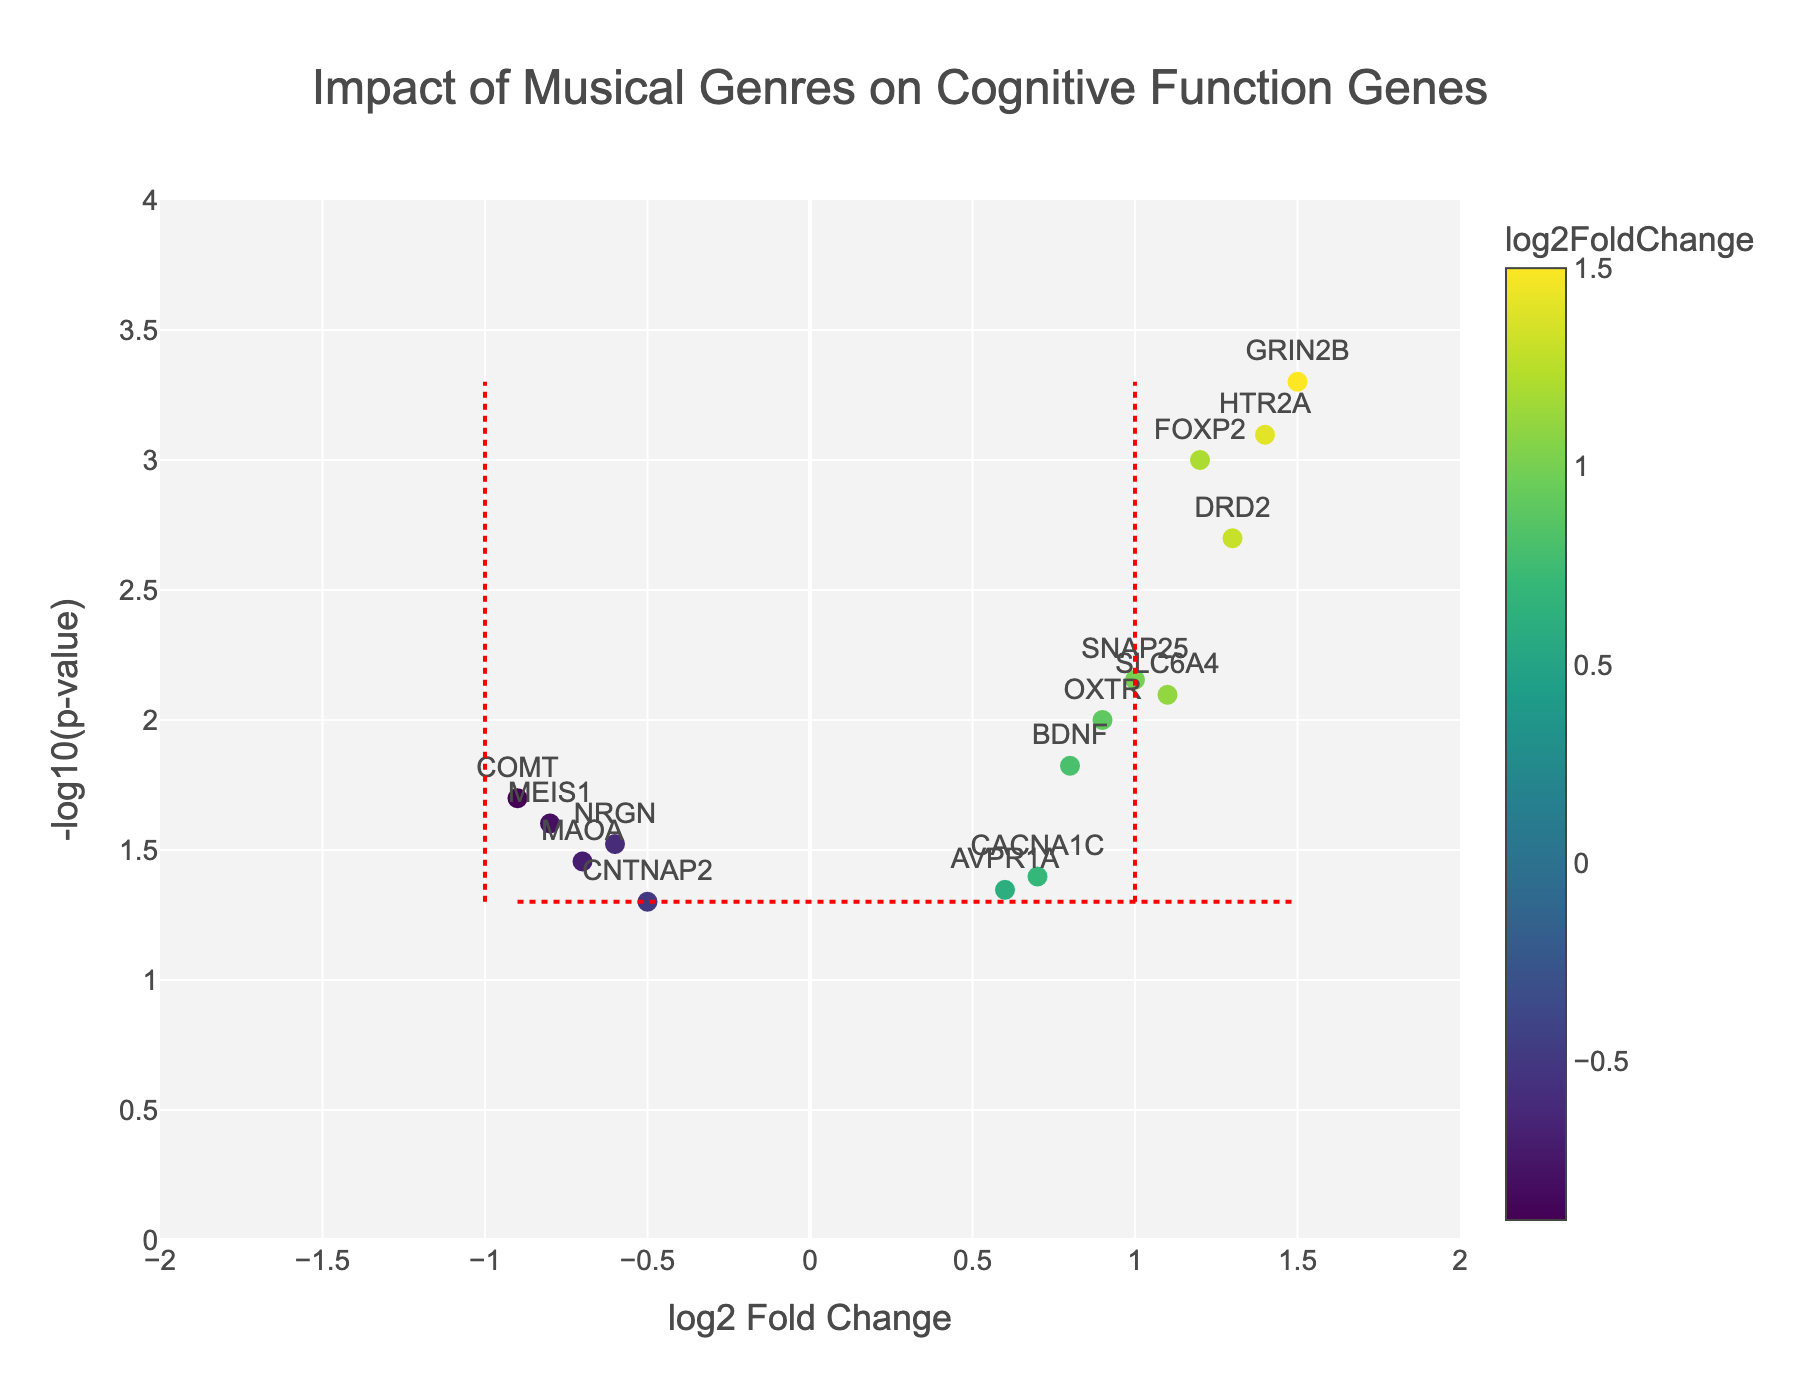Which gene has the highest -log10(p-value)? By looking at the y-axis, which represents -log10(p-value), the gene with the highest value can be identified.
Answer: GRIN2B What is the title of the plot? The title is usually located at the top of the figure and provides a brief description of what the plot represents.
Answer: Impact of Musical Genres on Cognitive Function Genes How many genes have a significant p-value (p < 0.05)? Significance is indicated by the horizontal line at -log10(0.05) ~ 1.3. Count the points above this line.
Answer: 13 Which gene shows the largest positive log2 fold change? Find the data point farthest to the right on the x-axis, representing the highest positive log2 fold change value.
Answer: GRIN2B Are there any genes with a negative log2 fold change and a p-value below 0.05? A gene with negative log2 fold change will be on the left side of the x-axis and above the horizontal line indicating p = 0.05.
Answer: Yes Which gene has the highest combination of log2 fold change and -log10(p-value)? This requires identifying the gene with the highest point above on the y-axis and furthest to the right on the x-axis.
Answer: GRIN2B Is there any gene that has a lower than average impact on cognitive function but is still significant? Identify genes with negative log2 fold change on the left side but above the significance threshold.
Answer: COMT Based on the log2 fold change, which gene has the minimal effect on cognitive function? The gene closest to the center (log2 fold change ~ 0) on the x-axis has the minimal effect.
Answer: NRGN How many genes fall above the threshold for a significant p-value but below a log2 fold change of 1? Count the points above the significance horizontal line, but within the x-axis values less than 1.
Answer: 7 